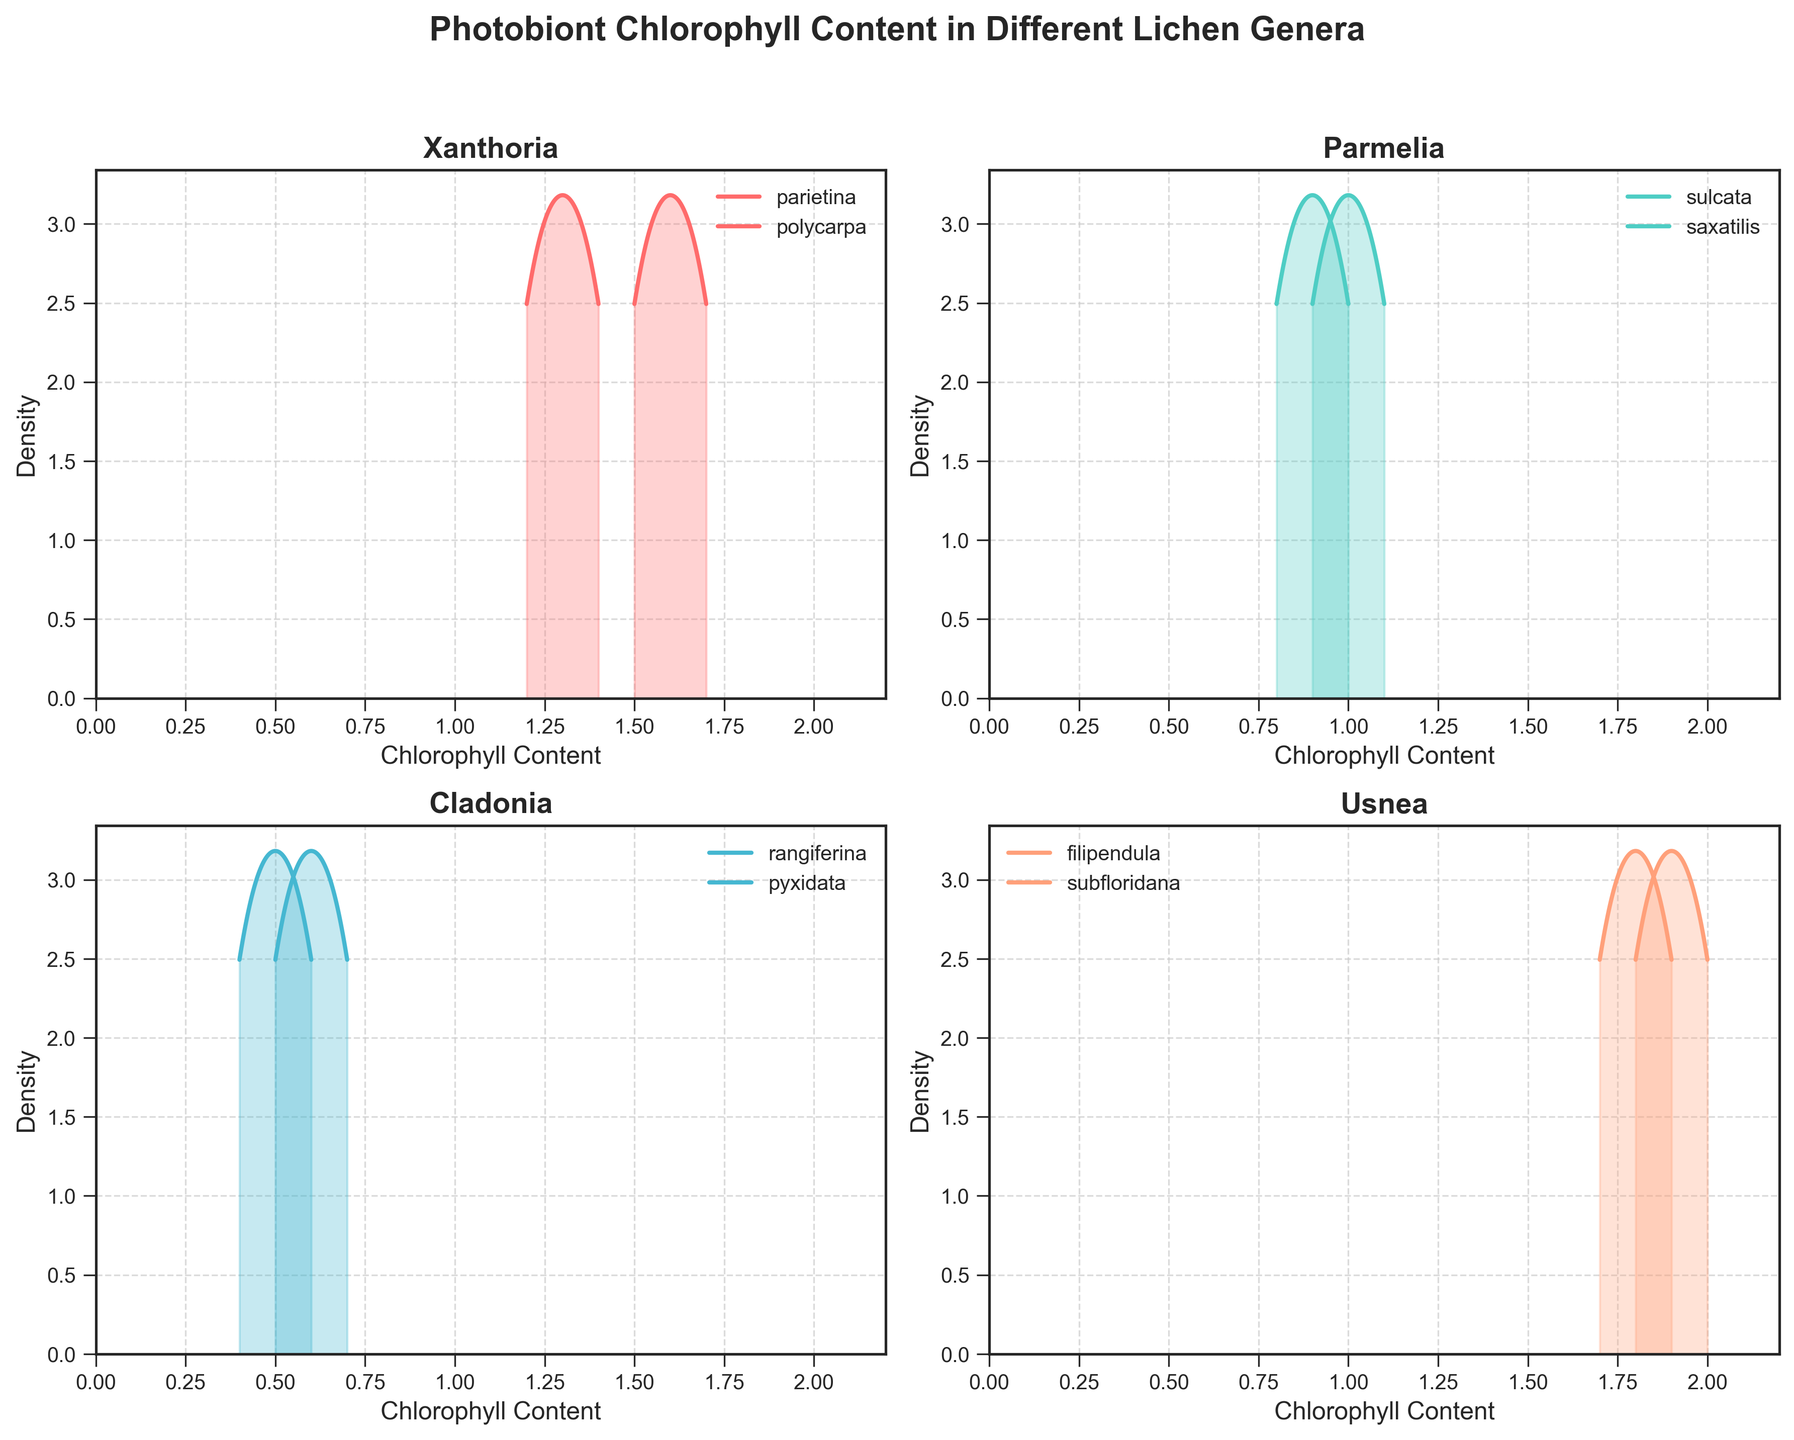What is the genus with the highest chlorophyll content range? The plot shows that the genus Usnea has the highest range of chlorophyll content, spanning from 1.7 to 2.0.
Answer: Usnea Which genus exhibits the widest range of chlorophyll content variation? The Usnea genus has chlorophyll content ranging from 1.7 to 2.0, which is the widest range compared to the other genera.
Answer: Usnea How many genera are represented in the plot? The title and individual subplots indicate that there are four genera: Xanthoria, Parmelia, Cladonia, and Usnea.
Answer: Four In which genus does the species Filipendula and Subfloridana appear? According to the plot, both Filipendula and Subfloridana are species within the genus Usnea.
Answer: Usnea What is the range of chlorophyll content in the genus Cladonia for the species rangiferina? The density plot for Cladonia shows that rangiferina has a chlorophyll content range from approximately 0.5 to 0.7.
Answer: 0.5 to 0.7 Which species within the genus Parmelia has the lower maximum chlorophyll content? The plot shows that Parmelia saxatilis has a lower maximum chlorophyll content (0.9) compared to Parmelia sulcata (1.1).
Answer: Parmelia saxatilis Does the genus Xanthoria show more variation in chlorophyll content compared to Cladonia? Xanthoria ranges from 1.2 to 1.7 in its species, whereas Cladonia ranges from 0.4 to 0.7, indicating Xanthoria shows more variation.
Answer: Yes What is the peak density value for any species in the genus Xanthoria? Xanthoria density plots show peaks around chlorophyll content values of approximately 1.3 for parietina and 1.6 for polycarpa
Answer: Approximately 1.3 and 1.6 How does the chlorophyll content of Usnea compare with other genera? Usnea shows the highest chlorophyll content among all genera, with values ranging from 1.7 to 2.0. Other genera have lower ranges.
Answer: Usnea has the highest content Which genus has species with chlorophyll content below 1.0? Both Parmelia and Cladonia have species with chlorophyll content below 1.0. For example, Parmelia saxatilis and all species within Cladonia.
Answer: Parmelia and Cladonia 